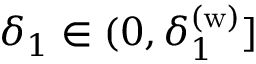<formula> <loc_0><loc_0><loc_500><loc_500>\delta _ { 1 } \in ( 0 , \delta _ { 1 } ^ { ( w ) } ]</formula> 